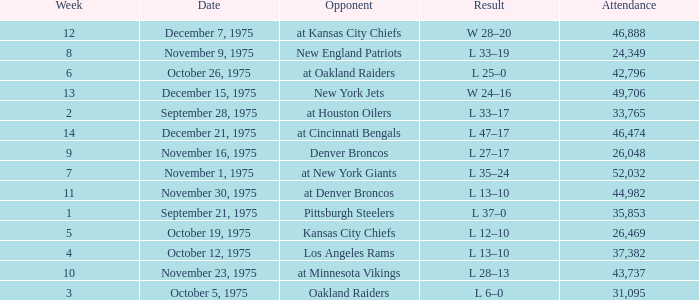What is the highest Week when the opponent was kansas city chiefs, with more than 26,469 in attendance? None. 